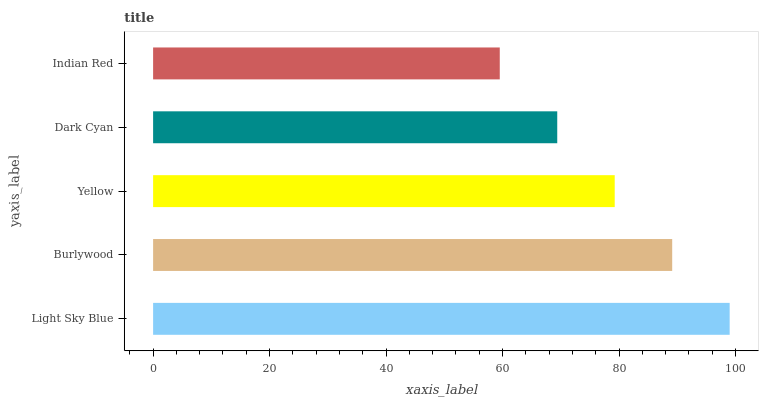Is Indian Red the minimum?
Answer yes or no. Yes. Is Light Sky Blue the maximum?
Answer yes or no. Yes. Is Burlywood the minimum?
Answer yes or no. No. Is Burlywood the maximum?
Answer yes or no. No. Is Light Sky Blue greater than Burlywood?
Answer yes or no. Yes. Is Burlywood less than Light Sky Blue?
Answer yes or no. Yes. Is Burlywood greater than Light Sky Blue?
Answer yes or no. No. Is Light Sky Blue less than Burlywood?
Answer yes or no. No. Is Yellow the high median?
Answer yes or no. Yes. Is Yellow the low median?
Answer yes or no. Yes. Is Light Sky Blue the high median?
Answer yes or no. No. Is Indian Red the low median?
Answer yes or no. No. 